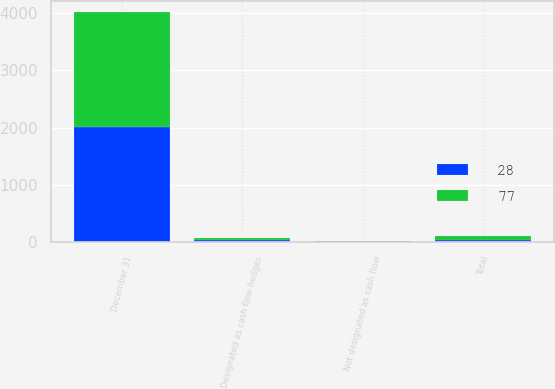<chart> <loc_0><loc_0><loc_500><loc_500><stacked_bar_chart><ecel><fcel>December 31<fcel>Designated as cash flow hedges<fcel>Not designated as cash flow<fcel>Total<nl><fcel>28<fcel>2009<fcel>37<fcel>12<fcel>28<nl><fcel>77<fcel>2008<fcel>40<fcel>12<fcel>77<nl></chart> 